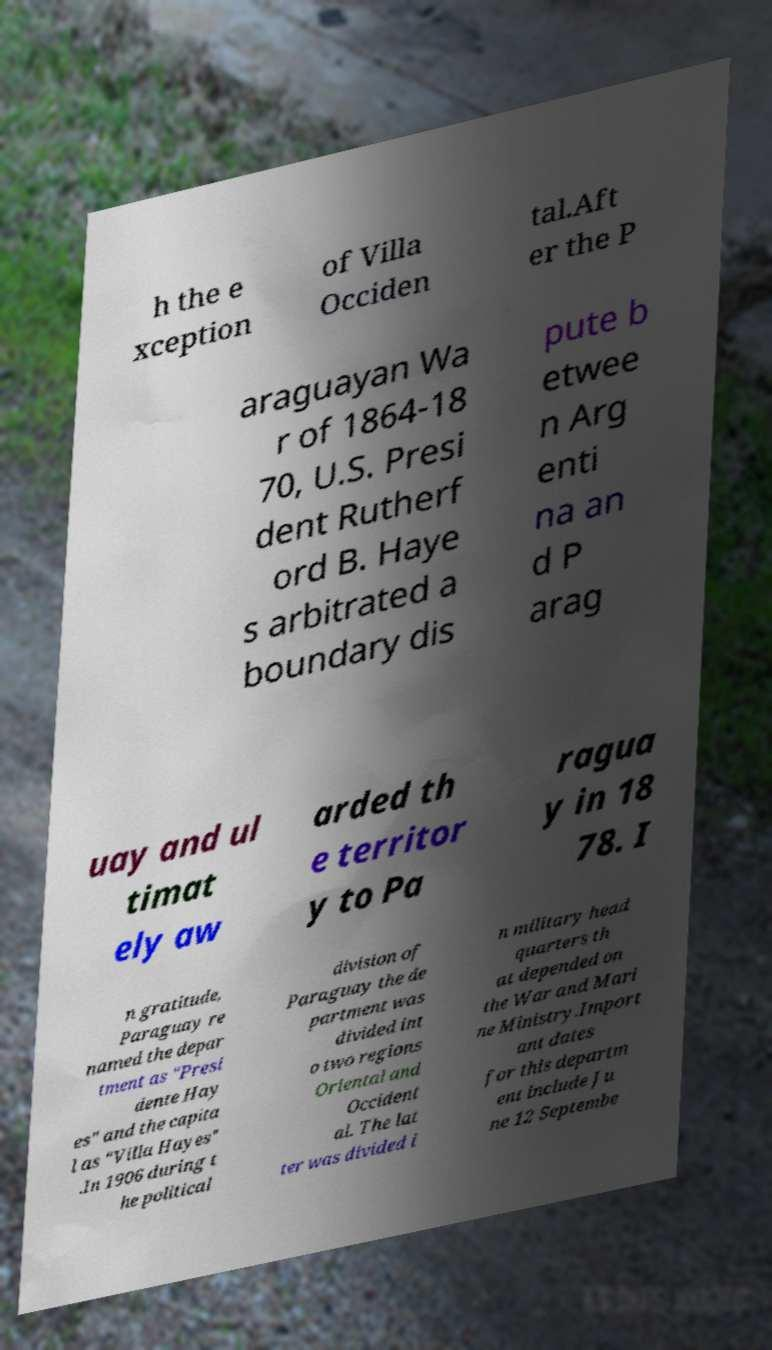Can you accurately transcribe the text from the provided image for me? h the e xception of Villa Occiden tal.Aft er the P araguayan Wa r of 1864-18 70, U.S. Presi dent Rutherf ord B. Haye s arbitrated a boundary dis pute b etwee n Arg enti na an d P arag uay and ul timat ely aw arded th e territor y to Pa ragua y in 18 78. I n gratitude, Paraguay re named the depar tment as "Presi dente Hay es" and the capita l as "Villa Hayes" .In 1906 during t he political division of Paraguay the de partment was divided int o two regions Oriental and Occident al. The lat ter was divided i n military head quarters th at depended on the War and Mari ne Ministry.Import ant dates for this departm ent include Ju ne 12 Septembe 